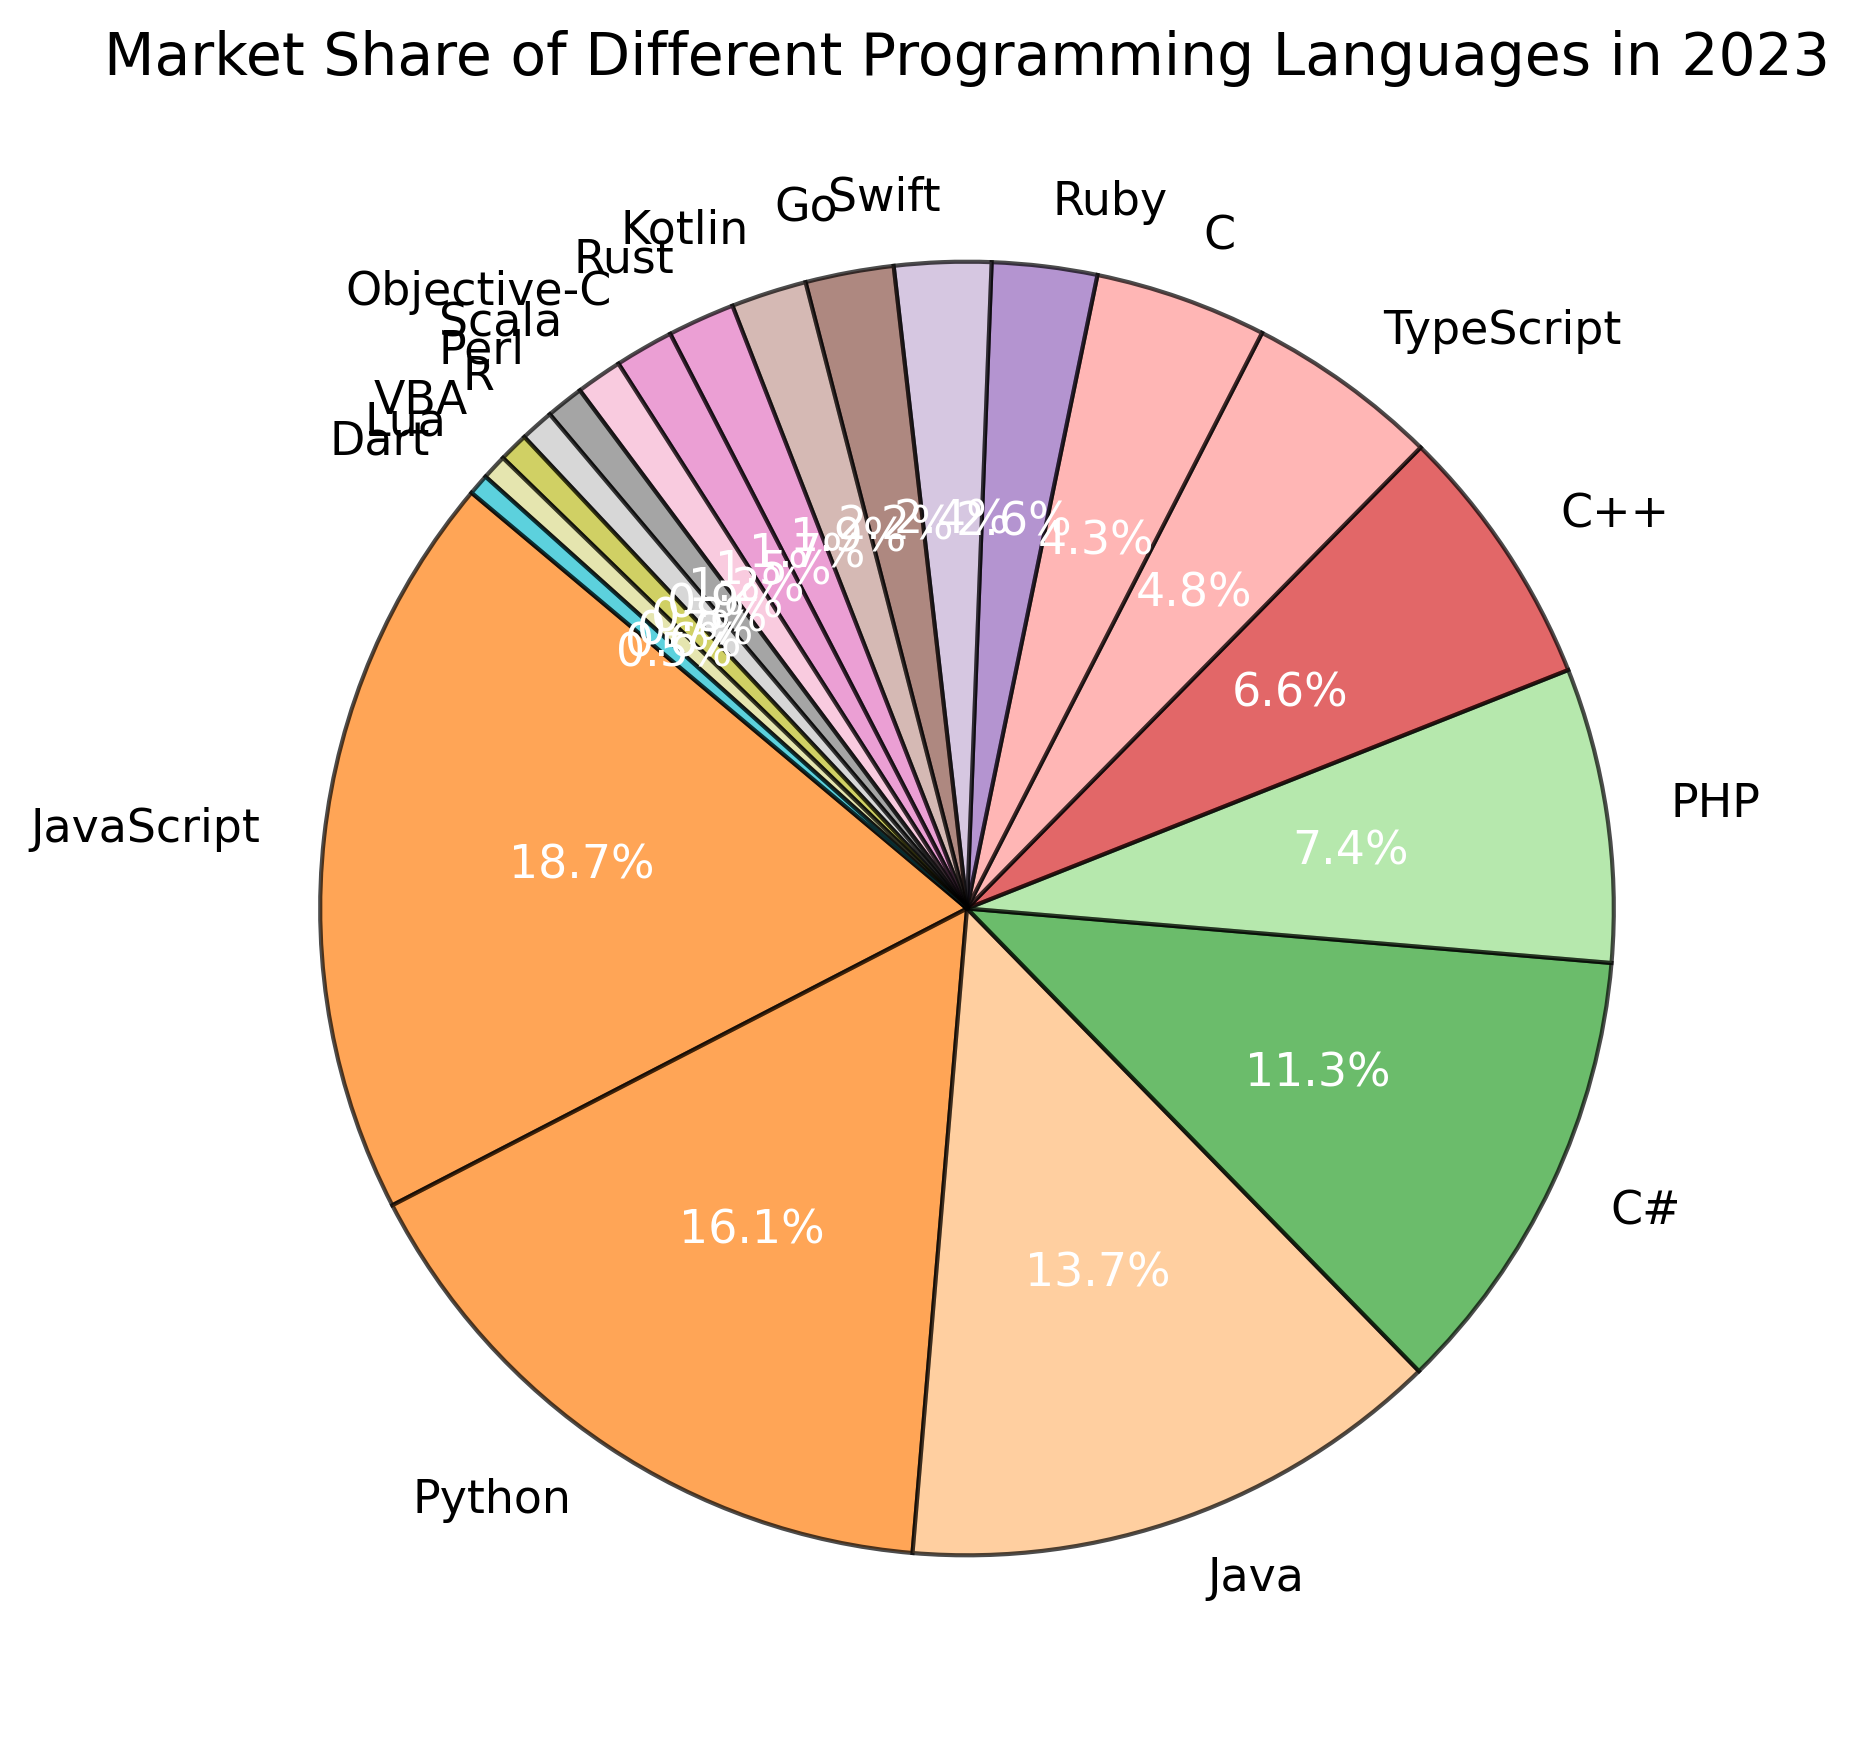What is the programming language with the highest market share? The pie chart shows the market share percentages of different programming languages. JavaScript has the highest market share as it occupies the largest slice.
Answer: JavaScript Compare the market share of Python and PHP. Which one has a higher share, and by how much? According to the chart, Python has a market share of 15.3%, and PHP has a market share of 7.0%. Subtract the smaller share from the larger one to find the difference. 15.3% - 7.0% = 8.3%
Answer: Python by 8.3% What percentage of the total market share is represented by C# and C++ combined? Find the market share values for C# (10.8%) and C++ (6.3%) in the chart. Add these two percentages together. 10.8% + 6.3% = 17.1%
Answer: 17.1% How does the market share of Java compare to that of C#? Look at the chart for the market share values of Java (13.0%) and C# (10.8%). Java has a higher market share than C#.
Answer: Java has a higher market share than C# Which language has the smallest market share, and what is its value? Identify the language with the smallest slice in the pie chart. Dart has the smallest market share, with a value of 0.5%.
Answer: Dart, 0.5% Is the market share of Python greater than the combined market share of Swift and Go? The market share of Python is 15.3%. The combined market share of Swift (2.3%) and Go (2.1%) is 2.3% + 2.1% = 4.4%. Since 15.3% is greater than 4.4%, Python has a greater market share.
Answer: Yes What is the total market share of all languages with less than 2% share each? Sum the market share values of Kotlin (1.8%), Rust (1.6%), Objective-C (1.4%), Scala (1.1%), Perl (0.9%), R (0.8%), VBA (0.7%), Lua (0.6%), and Dart (0.5%). 1.8% + 1.6% + 1.4% + 1.1% + 0.9% + 0.8% + 0.7% + 0.6% + 0.5% = 9.4%
Answer: 9.4% Identify the color associated with the market share of PHP in the pie chart. Look for the label "PHP" and observe the color of the corresponding slice in the pie chart. The slice representing PHP is typically a light brown or tan color in the chart.
Answer: Light brown/tan What is the combined market share of the top three programming languages? Find the market share values of the top three languages: JavaScript (17.8%), Python (15.3%), and Java (13.0%). Add these percentages together. 17.8% + 15.3% + 13.0% = 46.1%
Answer: 46.1% How does the market share of TypeScript compare to that of Swift? The chart shows TypeScript with a market share of 4.6% and Swift with a market share of 2.3%. TypeScript has twice the market share of Swift.
Answer: TypeScript has twice the market share of Swift 